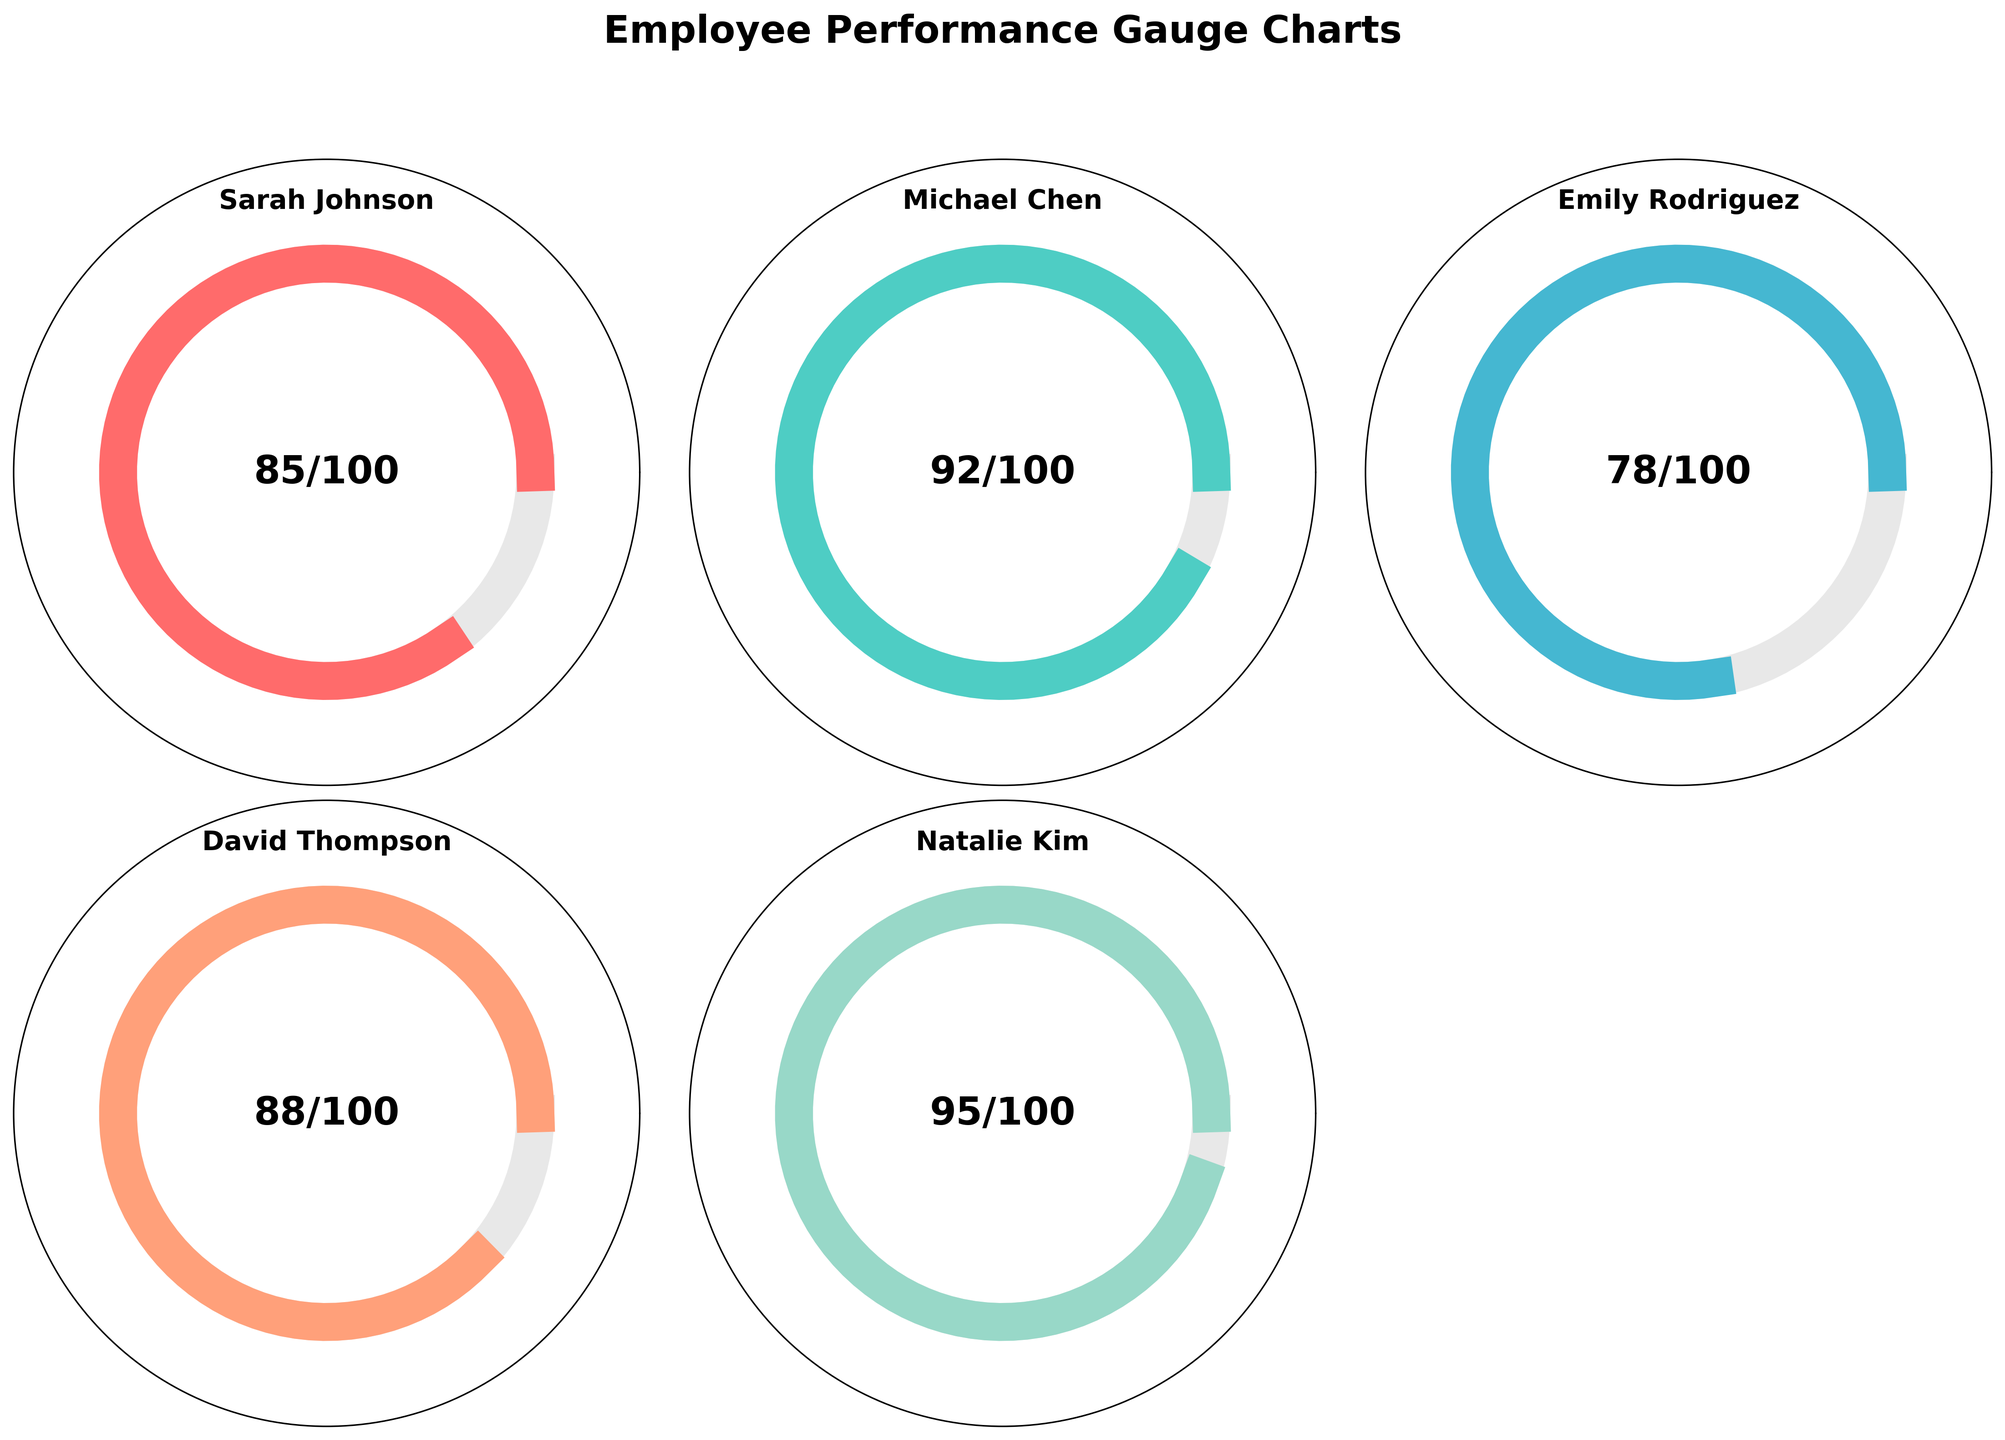What is the title of the figure? The title of the figure is written at the top and is "Employee Performance Gauge Charts".
Answer: Employee Performance Gauge Charts How many employees are represented in the figure? The figure contains one gauge chart for each employee, and there are five gauge charts shown.
Answer: Five Which employee has the highest performance score? By examining the scores displayed in the center of each gauge chart, Natalie Kim has the highest score of 95/100.
Answer: Natalie Kim Which employee has the lowest performance score? By examining the scores, Emily Rodriguez has the lowest score of 78/100.
Answer: Emily Rodriguez Are any two employees tied in their performance scores? By comparing the scores, none of the employees have the same performance score.
Answer: No What is the range of performance scores displayed in the figure? The highest performance score is 95, and the lowest is 78. The range is calculated by subtracting the lowest score from the highest score, 95 - 78.
Answer: 17 What is the average performance score of the employees? To find the average performance score, add all the scores (85 + 92 + 78 + 88 + 95) to get 438, then divide by the number of employees, which is 5. So, 438 / 5 = 87.6.
Answer: 87.6 What percentage of the maximum score did Michael Chen achieve? Michael Chen's performance score is 92 out of 100. The percentage is calculated by (92 / 100) * 100%.
Answer: 92% Who scored more, David Thompson or Emily Rodriguez, and by how much? David Thompson's score is 88, and Emily Rodriguez's score is 78. The difference is calculated by 88 - 78.
Answer: David Thompson by 10 What's the combined total of Sarah Johnson and Michael Chen's performance scores? Add Sarah Johnson's score of 85 and Michael Chen's score of 92. The total is 85 + 92.
Answer: 177 